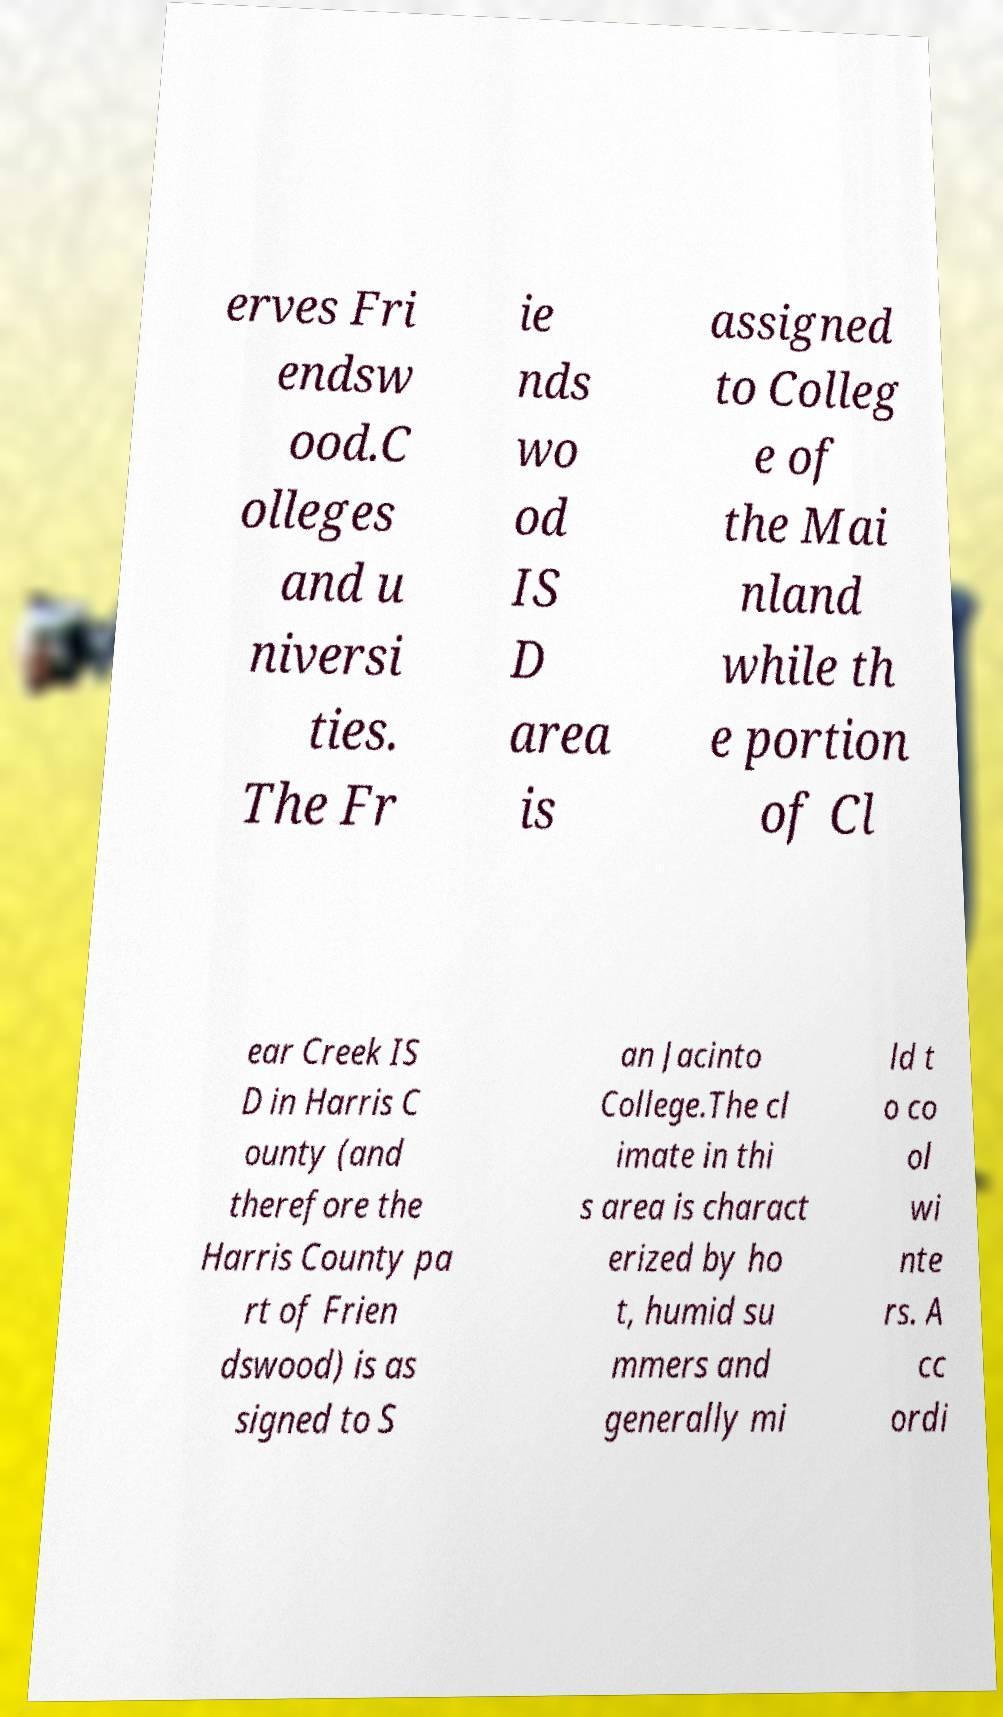Can you accurately transcribe the text from the provided image for me? erves Fri endsw ood.C olleges and u niversi ties. The Fr ie nds wo od IS D area is assigned to Colleg e of the Mai nland while th e portion of Cl ear Creek IS D in Harris C ounty (and therefore the Harris County pa rt of Frien dswood) is as signed to S an Jacinto College.The cl imate in thi s area is charact erized by ho t, humid su mmers and generally mi ld t o co ol wi nte rs. A cc ordi 